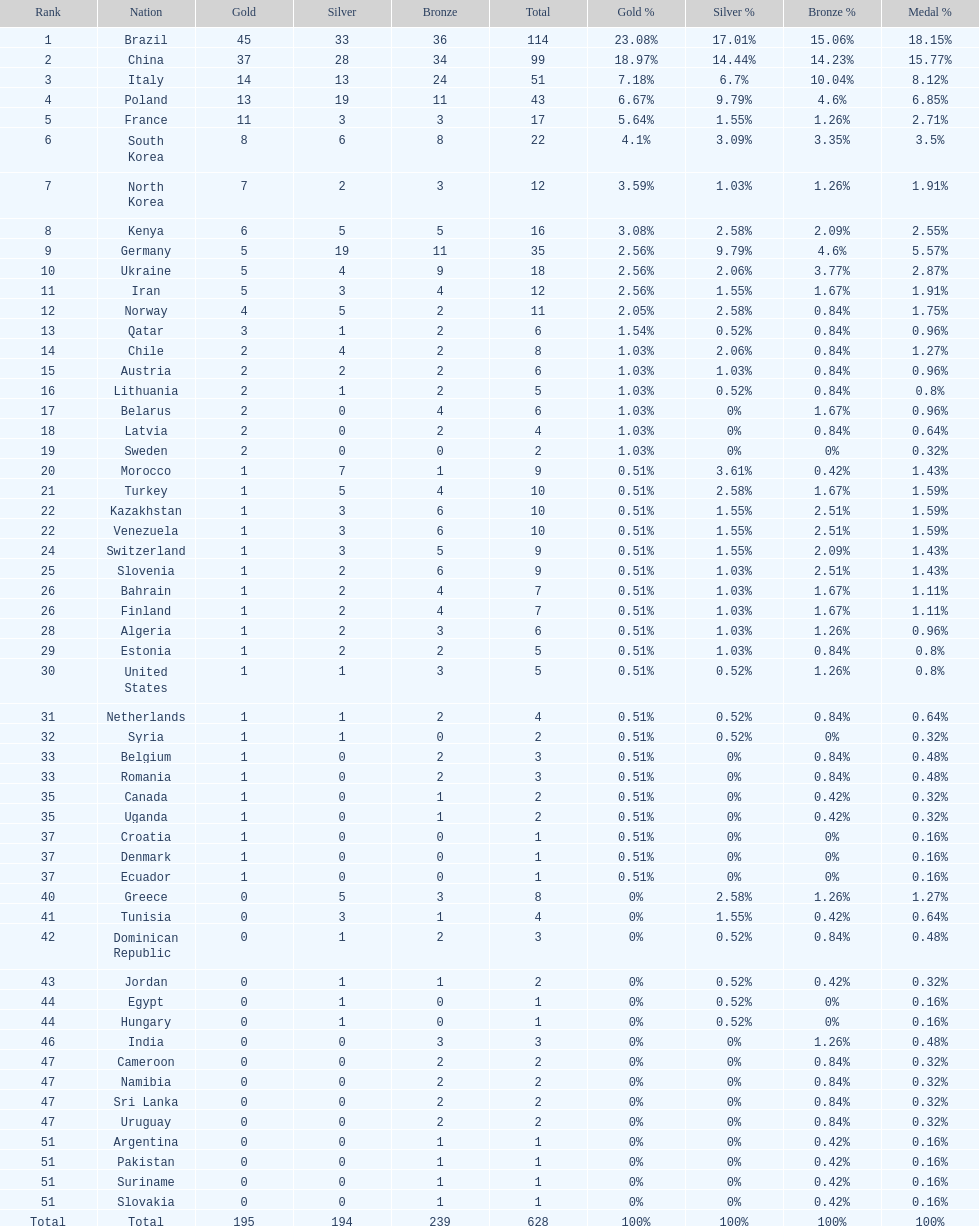How many more gold medals does china have over france? 26. 